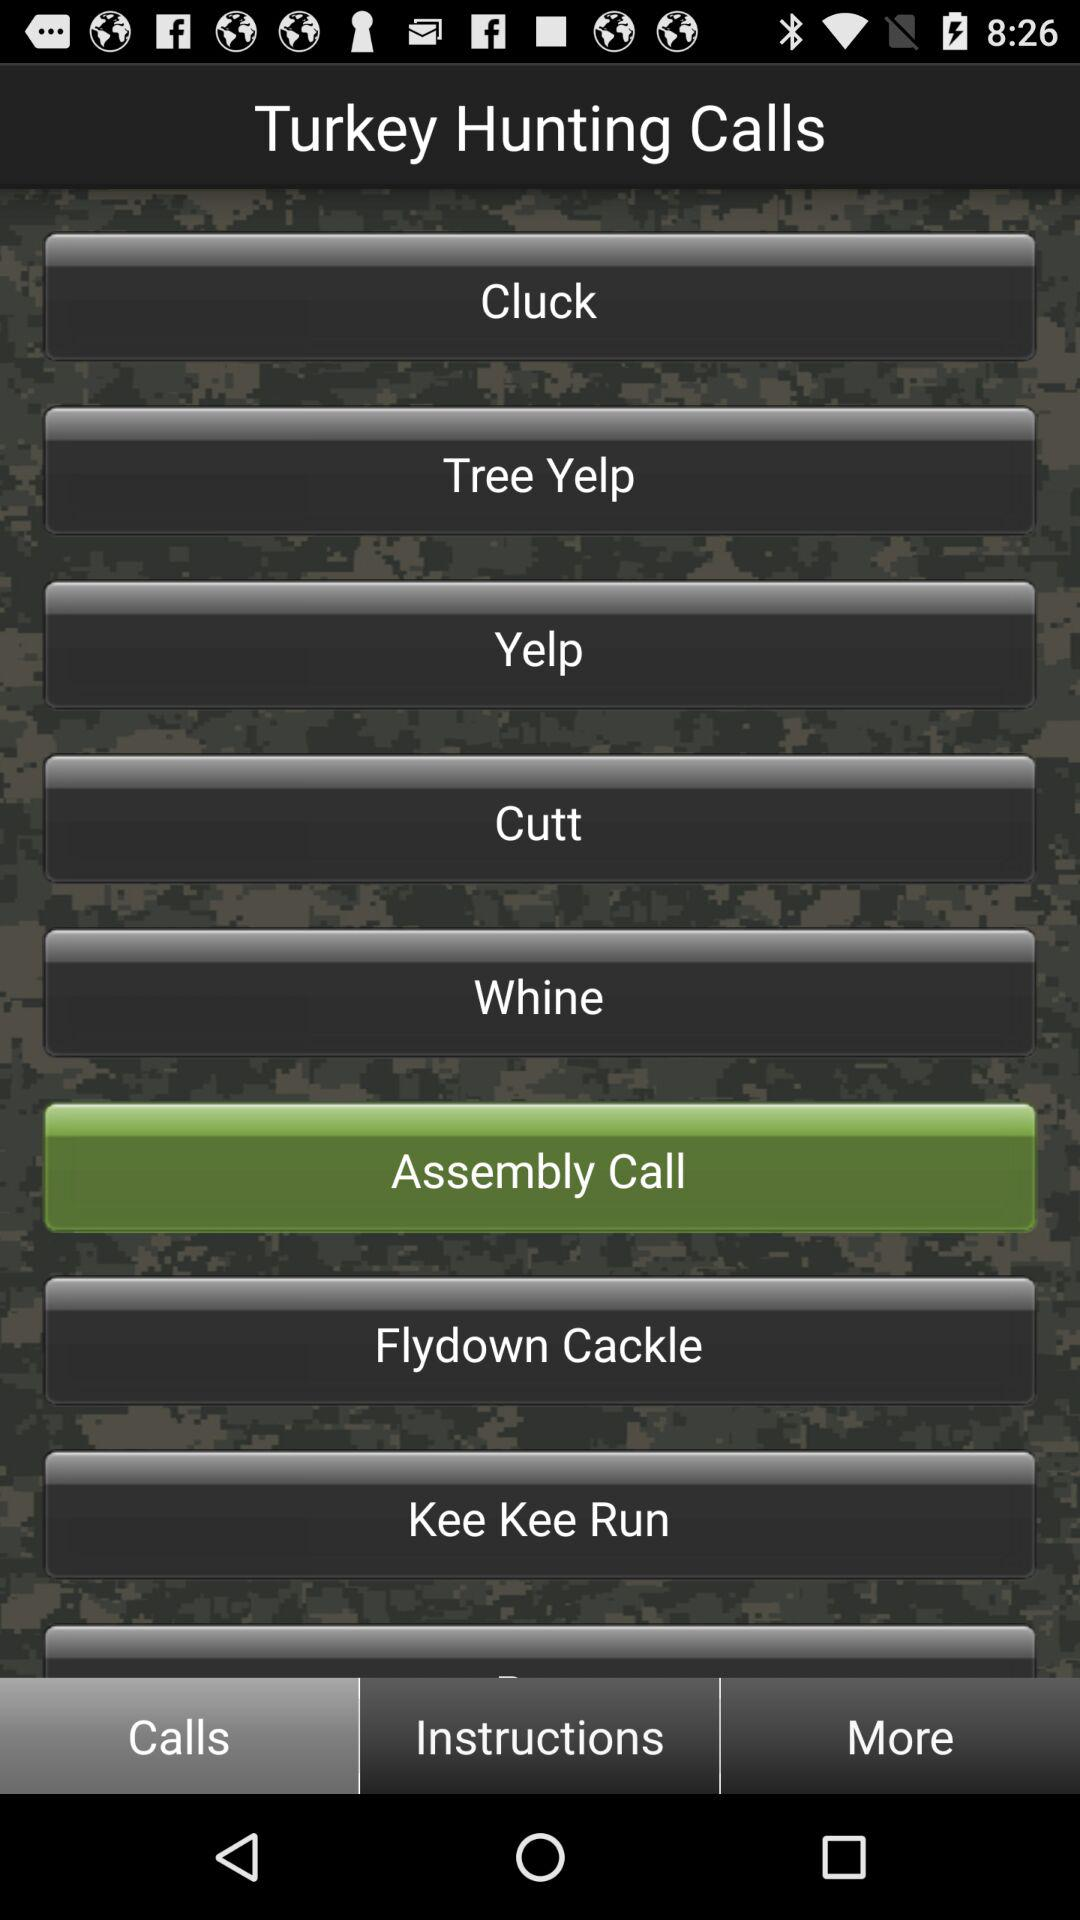Which call is selected in "Turkey Hunting Calls"? The call that is selected in "Turkey Hunting Calls" is "Assembly Call". 